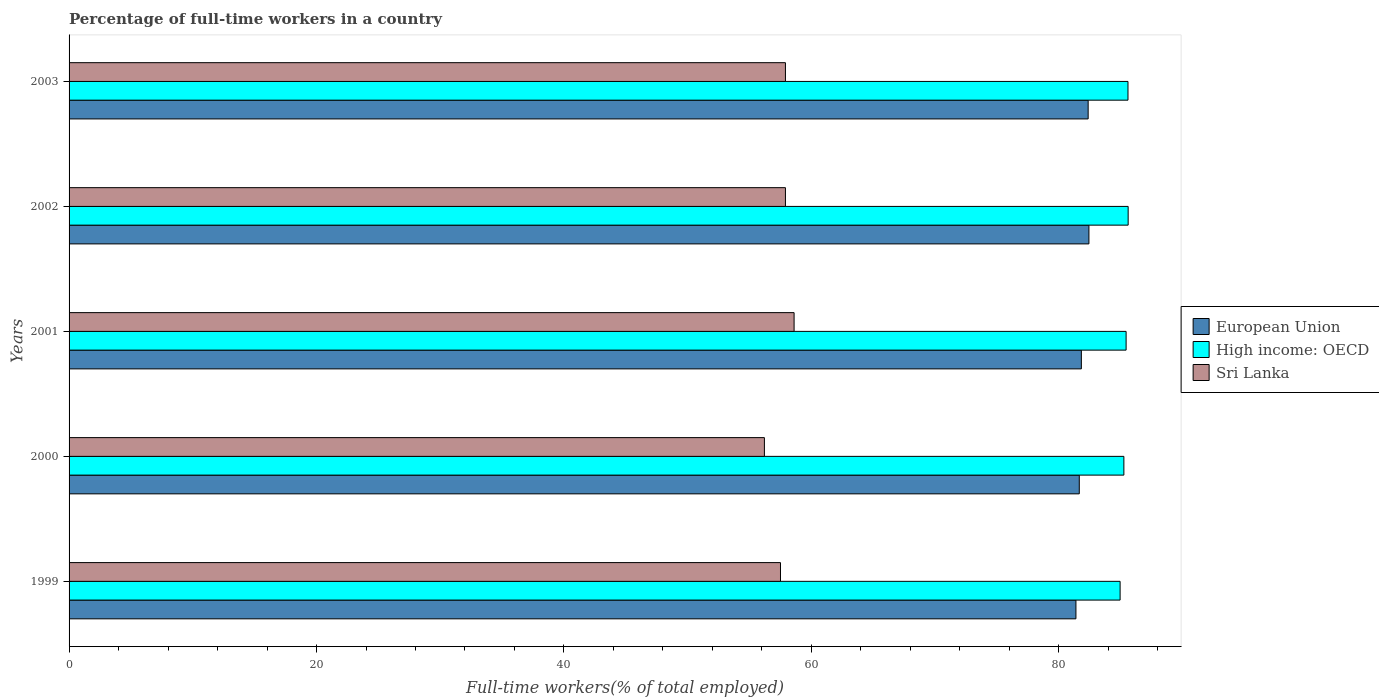How many bars are there on the 1st tick from the bottom?
Give a very brief answer. 3. In how many cases, is the number of bars for a given year not equal to the number of legend labels?
Your response must be concise. 0. What is the percentage of full-time workers in High income: OECD in 2002?
Offer a terse response. 85.6. Across all years, what is the maximum percentage of full-time workers in Sri Lanka?
Make the answer very short. 58.6. Across all years, what is the minimum percentage of full-time workers in Sri Lanka?
Your answer should be compact. 56.2. In which year was the percentage of full-time workers in Sri Lanka minimum?
Give a very brief answer. 2000. What is the total percentage of full-time workers in High income: OECD in the graph?
Ensure brevity in your answer.  426.83. What is the difference between the percentage of full-time workers in European Union in 1999 and that in 2001?
Ensure brevity in your answer.  -0.44. What is the difference between the percentage of full-time workers in High income: OECD in 1999 and the percentage of full-time workers in European Union in 2002?
Give a very brief answer. 2.52. What is the average percentage of full-time workers in European Union per year?
Keep it short and to the point. 81.93. In the year 2000, what is the difference between the percentage of full-time workers in Sri Lanka and percentage of full-time workers in European Union?
Offer a terse response. -25.45. What is the ratio of the percentage of full-time workers in European Union in 1999 to that in 2003?
Provide a short and direct response. 0.99. What is the difference between the highest and the second highest percentage of full-time workers in Sri Lanka?
Ensure brevity in your answer.  0.7. What is the difference between the highest and the lowest percentage of full-time workers in Sri Lanka?
Your response must be concise. 2.4. In how many years, is the percentage of full-time workers in Sri Lanka greater than the average percentage of full-time workers in Sri Lanka taken over all years?
Make the answer very short. 3. What does the 2nd bar from the bottom in 2001 represents?
Offer a very short reply. High income: OECD. Are all the bars in the graph horizontal?
Provide a short and direct response. Yes. How many years are there in the graph?
Offer a terse response. 5. Does the graph contain grids?
Offer a very short reply. No. How many legend labels are there?
Provide a short and direct response. 3. How are the legend labels stacked?
Your answer should be very brief. Vertical. What is the title of the graph?
Give a very brief answer. Percentage of full-time workers in a country. Does "Lower middle income" appear as one of the legend labels in the graph?
Your response must be concise. No. What is the label or title of the X-axis?
Ensure brevity in your answer.  Full-time workers(% of total employed). What is the label or title of the Y-axis?
Make the answer very short. Years. What is the Full-time workers(% of total employed) of European Union in 1999?
Offer a terse response. 81.38. What is the Full-time workers(% of total employed) in High income: OECD in 1999?
Keep it short and to the point. 84.95. What is the Full-time workers(% of total employed) of Sri Lanka in 1999?
Provide a short and direct response. 57.5. What is the Full-time workers(% of total employed) in European Union in 2000?
Provide a succinct answer. 81.65. What is the Full-time workers(% of total employed) of High income: OECD in 2000?
Ensure brevity in your answer.  85.25. What is the Full-time workers(% of total employed) in Sri Lanka in 2000?
Offer a terse response. 56.2. What is the Full-time workers(% of total employed) of European Union in 2001?
Ensure brevity in your answer.  81.82. What is the Full-time workers(% of total employed) in High income: OECD in 2001?
Keep it short and to the point. 85.44. What is the Full-time workers(% of total employed) in Sri Lanka in 2001?
Offer a very short reply. 58.6. What is the Full-time workers(% of total employed) in European Union in 2002?
Ensure brevity in your answer.  82.43. What is the Full-time workers(% of total employed) of High income: OECD in 2002?
Your answer should be compact. 85.6. What is the Full-time workers(% of total employed) in Sri Lanka in 2002?
Keep it short and to the point. 57.9. What is the Full-time workers(% of total employed) in European Union in 2003?
Offer a terse response. 82.37. What is the Full-time workers(% of total employed) in High income: OECD in 2003?
Ensure brevity in your answer.  85.59. What is the Full-time workers(% of total employed) in Sri Lanka in 2003?
Your answer should be compact. 57.9. Across all years, what is the maximum Full-time workers(% of total employed) in European Union?
Offer a very short reply. 82.43. Across all years, what is the maximum Full-time workers(% of total employed) in High income: OECD?
Make the answer very short. 85.6. Across all years, what is the maximum Full-time workers(% of total employed) of Sri Lanka?
Offer a terse response. 58.6. Across all years, what is the minimum Full-time workers(% of total employed) of European Union?
Offer a very short reply. 81.38. Across all years, what is the minimum Full-time workers(% of total employed) in High income: OECD?
Your answer should be very brief. 84.95. Across all years, what is the minimum Full-time workers(% of total employed) of Sri Lanka?
Your response must be concise. 56.2. What is the total Full-time workers(% of total employed) of European Union in the graph?
Offer a very short reply. 409.64. What is the total Full-time workers(% of total employed) of High income: OECD in the graph?
Your answer should be very brief. 426.83. What is the total Full-time workers(% of total employed) in Sri Lanka in the graph?
Make the answer very short. 288.1. What is the difference between the Full-time workers(% of total employed) in European Union in 1999 and that in 2000?
Keep it short and to the point. -0.27. What is the difference between the Full-time workers(% of total employed) in High income: OECD in 1999 and that in 2000?
Provide a succinct answer. -0.3. What is the difference between the Full-time workers(% of total employed) in European Union in 1999 and that in 2001?
Ensure brevity in your answer.  -0.44. What is the difference between the Full-time workers(% of total employed) of High income: OECD in 1999 and that in 2001?
Provide a succinct answer. -0.49. What is the difference between the Full-time workers(% of total employed) of Sri Lanka in 1999 and that in 2001?
Your answer should be very brief. -1.1. What is the difference between the Full-time workers(% of total employed) in European Union in 1999 and that in 2002?
Your answer should be very brief. -1.05. What is the difference between the Full-time workers(% of total employed) in High income: OECD in 1999 and that in 2002?
Your response must be concise. -0.65. What is the difference between the Full-time workers(% of total employed) of European Union in 1999 and that in 2003?
Keep it short and to the point. -0.99. What is the difference between the Full-time workers(% of total employed) of High income: OECD in 1999 and that in 2003?
Keep it short and to the point. -0.64. What is the difference between the Full-time workers(% of total employed) in European Union in 2000 and that in 2001?
Keep it short and to the point. -0.17. What is the difference between the Full-time workers(% of total employed) of High income: OECD in 2000 and that in 2001?
Your response must be concise. -0.18. What is the difference between the Full-time workers(% of total employed) in Sri Lanka in 2000 and that in 2001?
Your answer should be compact. -2.4. What is the difference between the Full-time workers(% of total employed) of European Union in 2000 and that in 2002?
Your response must be concise. -0.78. What is the difference between the Full-time workers(% of total employed) of High income: OECD in 2000 and that in 2002?
Your response must be concise. -0.35. What is the difference between the Full-time workers(% of total employed) of European Union in 2000 and that in 2003?
Ensure brevity in your answer.  -0.72. What is the difference between the Full-time workers(% of total employed) in High income: OECD in 2000 and that in 2003?
Your answer should be very brief. -0.33. What is the difference between the Full-time workers(% of total employed) in Sri Lanka in 2000 and that in 2003?
Your response must be concise. -1.7. What is the difference between the Full-time workers(% of total employed) in European Union in 2001 and that in 2002?
Provide a succinct answer. -0.61. What is the difference between the Full-time workers(% of total employed) of High income: OECD in 2001 and that in 2002?
Give a very brief answer. -0.17. What is the difference between the Full-time workers(% of total employed) in Sri Lanka in 2001 and that in 2002?
Your response must be concise. 0.7. What is the difference between the Full-time workers(% of total employed) in European Union in 2001 and that in 2003?
Keep it short and to the point. -0.55. What is the difference between the Full-time workers(% of total employed) in High income: OECD in 2001 and that in 2003?
Ensure brevity in your answer.  -0.15. What is the difference between the Full-time workers(% of total employed) in European Union in 2002 and that in 2003?
Offer a very short reply. 0.06. What is the difference between the Full-time workers(% of total employed) in High income: OECD in 2002 and that in 2003?
Your response must be concise. 0.01. What is the difference between the Full-time workers(% of total employed) in European Union in 1999 and the Full-time workers(% of total employed) in High income: OECD in 2000?
Give a very brief answer. -3.88. What is the difference between the Full-time workers(% of total employed) of European Union in 1999 and the Full-time workers(% of total employed) of Sri Lanka in 2000?
Provide a succinct answer. 25.18. What is the difference between the Full-time workers(% of total employed) of High income: OECD in 1999 and the Full-time workers(% of total employed) of Sri Lanka in 2000?
Make the answer very short. 28.75. What is the difference between the Full-time workers(% of total employed) in European Union in 1999 and the Full-time workers(% of total employed) in High income: OECD in 2001?
Keep it short and to the point. -4.06. What is the difference between the Full-time workers(% of total employed) in European Union in 1999 and the Full-time workers(% of total employed) in Sri Lanka in 2001?
Your answer should be very brief. 22.78. What is the difference between the Full-time workers(% of total employed) of High income: OECD in 1999 and the Full-time workers(% of total employed) of Sri Lanka in 2001?
Offer a very short reply. 26.35. What is the difference between the Full-time workers(% of total employed) in European Union in 1999 and the Full-time workers(% of total employed) in High income: OECD in 2002?
Provide a short and direct response. -4.22. What is the difference between the Full-time workers(% of total employed) of European Union in 1999 and the Full-time workers(% of total employed) of Sri Lanka in 2002?
Provide a short and direct response. 23.48. What is the difference between the Full-time workers(% of total employed) in High income: OECD in 1999 and the Full-time workers(% of total employed) in Sri Lanka in 2002?
Make the answer very short. 27.05. What is the difference between the Full-time workers(% of total employed) in European Union in 1999 and the Full-time workers(% of total employed) in High income: OECD in 2003?
Offer a terse response. -4.21. What is the difference between the Full-time workers(% of total employed) in European Union in 1999 and the Full-time workers(% of total employed) in Sri Lanka in 2003?
Offer a terse response. 23.48. What is the difference between the Full-time workers(% of total employed) in High income: OECD in 1999 and the Full-time workers(% of total employed) in Sri Lanka in 2003?
Offer a terse response. 27.05. What is the difference between the Full-time workers(% of total employed) of European Union in 2000 and the Full-time workers(% of total employed) of High income: OECD in 2001?
Ensure brevity in your answer.  -3.79. What is the difference between the Full-time workers(% of total employed) of European Union in 2000 and the Full-time workers(% of total employed) of Sri Lanka in 2001?
Ensure brevity in your answer.  23.05. What is the difference between the Full-time workers(% of total employed) in High income: OECD in 2000 and the Full-time workers(% of total employed) in Sri Lanka in 2001?
Your answer should be very brief. 26.65. What is the difference between the Full-time workers(% of total employed) in European Union in 2000 and the Full-time workers(% of total employed) in High income: OECD in 2002?
Provide a short and direct response. -3.95. What is the difference between the Full-time workers(% of total employed) of European Union in 2000 and the Full-time workers(% of total employed) of Sri Lanka in 2002?
Offer a terse response. 23.75. What is the difference between the Full-time workers(% of total employed) in High income: OECD in 2000 and the Full-time workers(% of total employed) in Sri Lanka in 2002?
Give a very brief answer. 27.35. What is the difference between the Full-time workers(% of total employed) in European Union in 2000 and the Full-time workers(% of total employed) in High income: OECD in 2003?
Offer a very short reply. -3.94. What is the difference between the Full-time workers(% of total employed) in European Union in 2000 and the Full-time workers(% of total employed) in Sri Lanka in 2003?
Offer a very short reply. 23.75. What is the difference between the Full-time workers(% of total employed) of High income: OECD in 2000 and the Full-time workers(% of total employed) of Sri Lanka in 2003?
Give a very brief answer. 27.35. What is the difference between the Full-time workers(% of total employed) in European Union in 2001 and the Full-time workers(% of total employed) in High income: OECD in 2002?
Provide a short and direct response. -3.78. What is the difference between the Full-time workers(% of total employed) of European Union in 2001 and the Full-time workers(% of total employed) of Sri Lanka in 2002?
Provide a short and direct response. 23.92. What is the difference between the Full-time workers(% of total employed) of High income: OECD in 2001 and the Full-time workers(% of total employed) of Sri Lanka in 2002?
Provide a short and direct response. 27.54. What is the difference between the Full-time workers(% of total employed) of European Union in 2001 and the Full-time workers(% of total employed) of High income: OECD in 2003?
Provide a succinct answer. -3.77. What is the difference between the Full-time workers(% of total employed) in European Union in 2001 and the Full-time workers(% of total employed) in Sri Lanka in 2003?
Offer a very short reply. 23.92. What is the difference between the Full-time workers(% of total employed) in High income: OECD in 2001 and the Full-time workers(% of total employed) in Sri Lanka in 2003?
Your answer should be very brief. 27.54. What is the difference between the Full-time workers(% of total employed) of European Union in 2002 and the Full-time workers(% of total employed) of High income: OECD in 2003?
Provide a succinct answer. -3.16. What is the difference between the Full-time workers(% of total employed) of European Union in 2002 and the Full-time workers(% of total employed) of Sri Lanka in 2003?
Your response must be concise. 24.53. What is the difference between the Full-time workers(% of total employed) of High income: OECD in 2002 and the Full-time workers(% of total employed) of Sri Lanka in 2003?
Your answer should be compact. 27.7. What is the average Full-time workers(% of total employed) in European Union per year?
Offer a terse response. 81.93. What is the average Full-time workers(% of total employed) of High income: OECD per year?
Ensure brevity in your answer.  85.37. What is the average Full-time workers(% of total employed) in Sri Lanka per year?
Provide a short and direct response. 57.62. In the year 1999, what is the difference between the Full-time workers(% of total employed) in European Union and Full-time workers(% of total employed) in High income: OECD?
Provide a short and direct response. -3.57. In the year 1999, what is the difference between the Full-time workers(% of total employed) in European Union and Full-time workers(% of total employed) in Sri Lanka?
Offer a terse response. 23.88. In the year 1999, what is the difference between the Full-time workers(% of total employed) of High income: OECD and Full-time workers(% of total employed) of Sri Lanka?
Ensure brevity in your answer.  27.45. In the year 2000, what is the difference between the Full-time workers(% of total employed) of European Union and Full-time workers(% of total employed) of High income: OECD?
Your response must be concise. -3.6. In the year 2000, what is the difference between the Full-time workers(% of total employed) of European Union and Full-time workers(% of total employed) of Sri Lanka?
Provide a succinct answer. 25.45. In the year 2000, what is the difference between the Full-time workers(% of total employed) of High income: OECD and Full-time workers(% of total employed) of Sri Lanka?
Keep it short and to the point. 29.05. In the year 2001, what is the difference between the Full-time workers(% of total employed) in European Union and Full-time workers(% of total employed) in High income: OECD?
Your response must be concise. -3.62. In the year 2001, what is the difference between the Full-time workers(% of total employed) in European Union and Full-time workers(% of total employed) in Sri Lanka?
Provide a succinct answer. 23.22. In the year 2001, what is the difference between the Full-time workers(% of total employed) of High income: OECD and Full-time workers(% of total employed) of Sri Lanka?
Provide a succinct answer. 26.84. In the year 2002, what is the difference between the Full-time workers(% of total employed) in European Union and Full-time workers(% of total employed) in High income: OECD?
Your answer should be compact. -3.17. In the year 2002, what is the difference between the Full-time workers(% of total employed) of European Union and Full-time workers(% of total employed) of Sri Lanka?
Keep it short and to the point. 24.53. In the year 2002, what is the difference between the Full-time workers(% of total employed) of High income: OECD and Full-time workers(% of total employed) of Sri Lanka?
Provide a short and direct response. 27.7. In the year 2003, what is the difference between the Full-time workers(% of total employed) in European Union and Full-time workers(% of total employed) in High income: OECD?
Your response must be concise. -3.22. In the year 2003, what is the difference between the Full-time workers(% of total employed) of European Union and Full-time workers(% of total employed) of Sri Lanka?
Provide a succinct answer. 24.47. In the year 2003, what is the difference between the Full-time workers(% of total employed) of High income: OECD and Full-time workers(% of total employed) of Sri Lanka?
Your answer should be very brief. 27.69. What is the ratio of the Full-time workers(% of total employed) in European Union in 1999 to that in 2000?
Keep it short and to the point. 1. What is the ratio of the Full-time workers(% of total employed) of Sri Lanka in 1999 to that in 2000?
Offer a terse response. 1.02. What is the ratio of the Full-time workers(% of total employed) in Sri Lanka in 1999 to that in 2001?
Make the answer very short. 0.98. What is the ratio of the Full-time workers(% of total employed) of European Union in 1999 to that in 2002?
Keep it short and to the point. 0.99. What is the ratio of the Full-time workers(% of total employed) in Sri Lanka in 1999 to that in 2002?
Provide a succinct answer. 0.99. What is the ratio of the Full-time workers(% of total employed) in European Union in 1999 to that in 2003?
Offer a terse response. 0.99. What is the ratio of the Full-time workers(% of total employed) in High income: OECD in 1999 to that in 2003?
Give a very brief answer. 0.99. What is the ratio of the Full-time workers(% of total employed) in Sri Lanka in 1999 to that in 2003?
Keep it short and to the point. 0.99. What is the ratio of the Full-time workers(% of total employed) in European Union in 2000 to that in 2001?
Provide a short and direct response. 1. What is the ratio of the Full-time workers(% of total employed) of High income: OECD in 2000 to that in 2001?
Make the answer very short. 1. What is the ratio of the Full-time workers(% of total employed) in Sri Lanka in 2000 to that in 2001?
Provide a short and direct response. 0.96. What is the ratio of the Full-time workers(% of total employed) in High income: OECD in 2000 to that in 2002?
Offer a very short reply. 1. What is the ratio of the Full-time workers(% of total employed) in Sri Lanka in 2000 to that in 2002?
Your response must be concise. 0.97. What is the ratio of the Full-time workers(% of total employed) of European Union in 2000 to that in 2003?
Offer a terse response. 0.99. What is the ratio of the Full-time workers(% of total employed) of Sri Lanka in 2000 to that in 2003?
Your answer should be very brief. 0.97. What is the ratio of the Full-time workers(% of total employed) in European Union in 2001 to that in 2002?
Make the answer very short. 0.99. What is the ratio of the Full-time workers(% of total employed) in High income: OECD in 2001 to that in 2002?
Offer a terse response. 1. What is the ratio of the Full-time workers(% of total employed) in Sri Lanka in 2001 to that in 2002?
Your answer should be very brief. 1.01. What is the ratio of the Full-time workers(% of total employed) in Sri Lanka in 2001 to that in 2003?
Offer a terse response. 1.01. What is the ratio of the Full-time workers(% of total employed) in High income: OECD in 2002 to that in 2003?
Give a very brief answer. 1. What is the difference between the highest and the second highest Full-time workers(% of total employed) in European Union?
Give a very brief answer. 0.06. What is the difference between the highest and the second highest Full-time workers(% of total employed) in High income: OECD?
Offer a terse response. 0.01. What is the difference between the highest and the second highest Full-time workers(% of total employed) in Sri Lanka?
Provide a succinct answer. 0.7. What is the difference between the highest and the lowest Full-time workers(% of total employed) of European Union?
Your answer should be very brief. 1.05. What is the difference between the highest and the lowest Full-time workers(% of total employed) in High income: OECD?
Give a very brief answer. 0.65. 